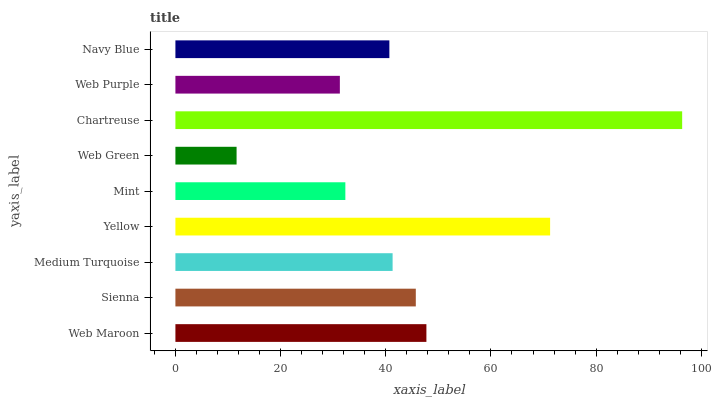Is Web Green the minimum?
Answer yes or no. Yes. Is Chartreuse the maximum?
Answer yes or no. Yes. Is Sienna the minimum?
Answer yes or no. No. Is Sienna the maximum?
Answer yes or no. No. Is Web Maroon greater than Sienna?
Answer yes or no. Yes. Is Sienna less than Web Maroon?
Answer yes or no. Yes. Is Sienna greater than Web Maroon?
Answer yes or no. No. Is Web Maroon less than Sienna?
Answer yes or no. No. Is Medium Turquoise the high median?
Answer yes or no. Yes. Is Medium Turquoise the low median?
Answer yes or no. Yes. Is Chartreuse the high median?
Answer yes or no. No. Is Chartreuse the low median?
Answer yes or no. No. 